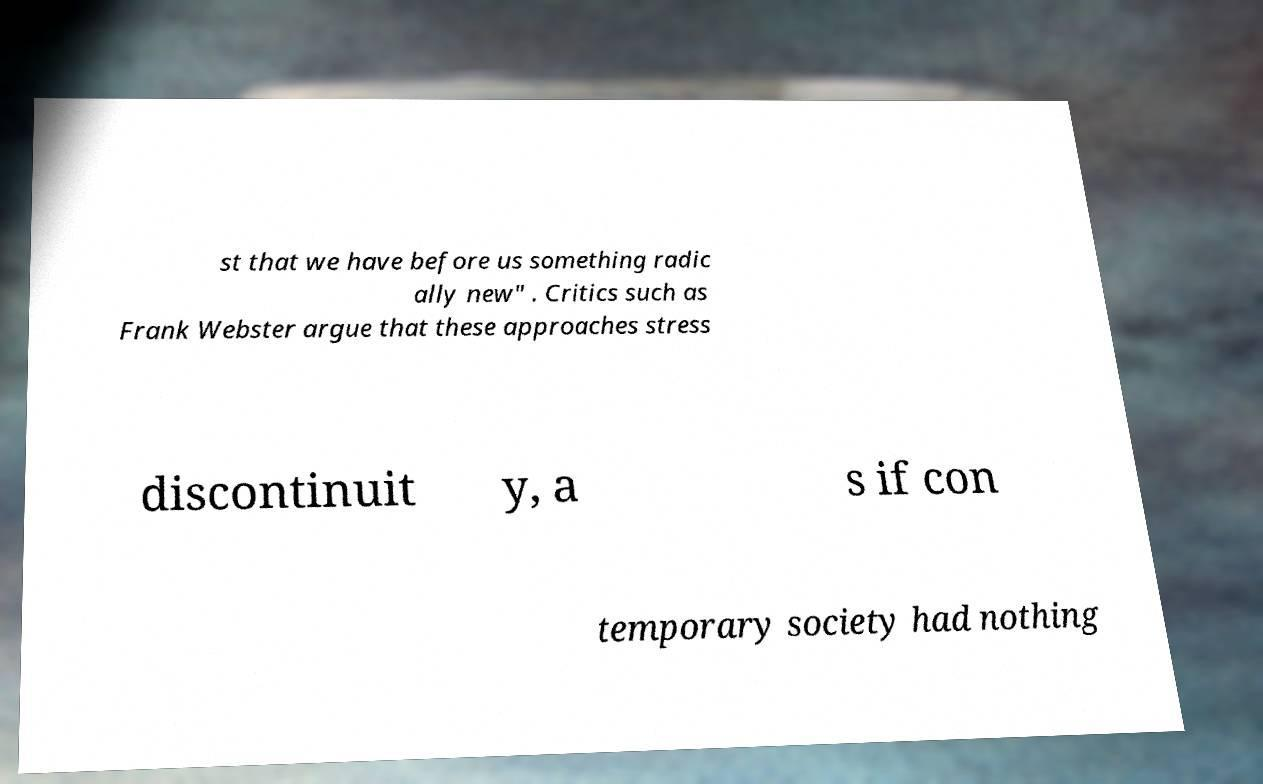Please read and relay the text visible in this image. What does it say? st that we have before us something radic ally new" . Critics such as Frank Webster argue that these approaches stress discontinuit y, a s if con temporary society had nothing 